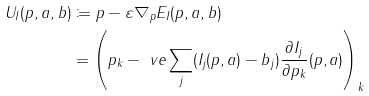Convert formula to latex. <formula><loc_0><loc_0><loc_500><loc_500>U _ { I } ( p , a , b ) & \coloneqq p - \varepsilon \nabla _ { p } E _ { I } ( p , a , b ) \\ & = \left ( p _ { k } - \ v e \sum _ { j } ( I _ { j } ( p , a ) - b _ { j } ) \frac { \partial I _ { j } } { \partial p _ { k } } ( p , a ) \right ) _ { k }</formula> 